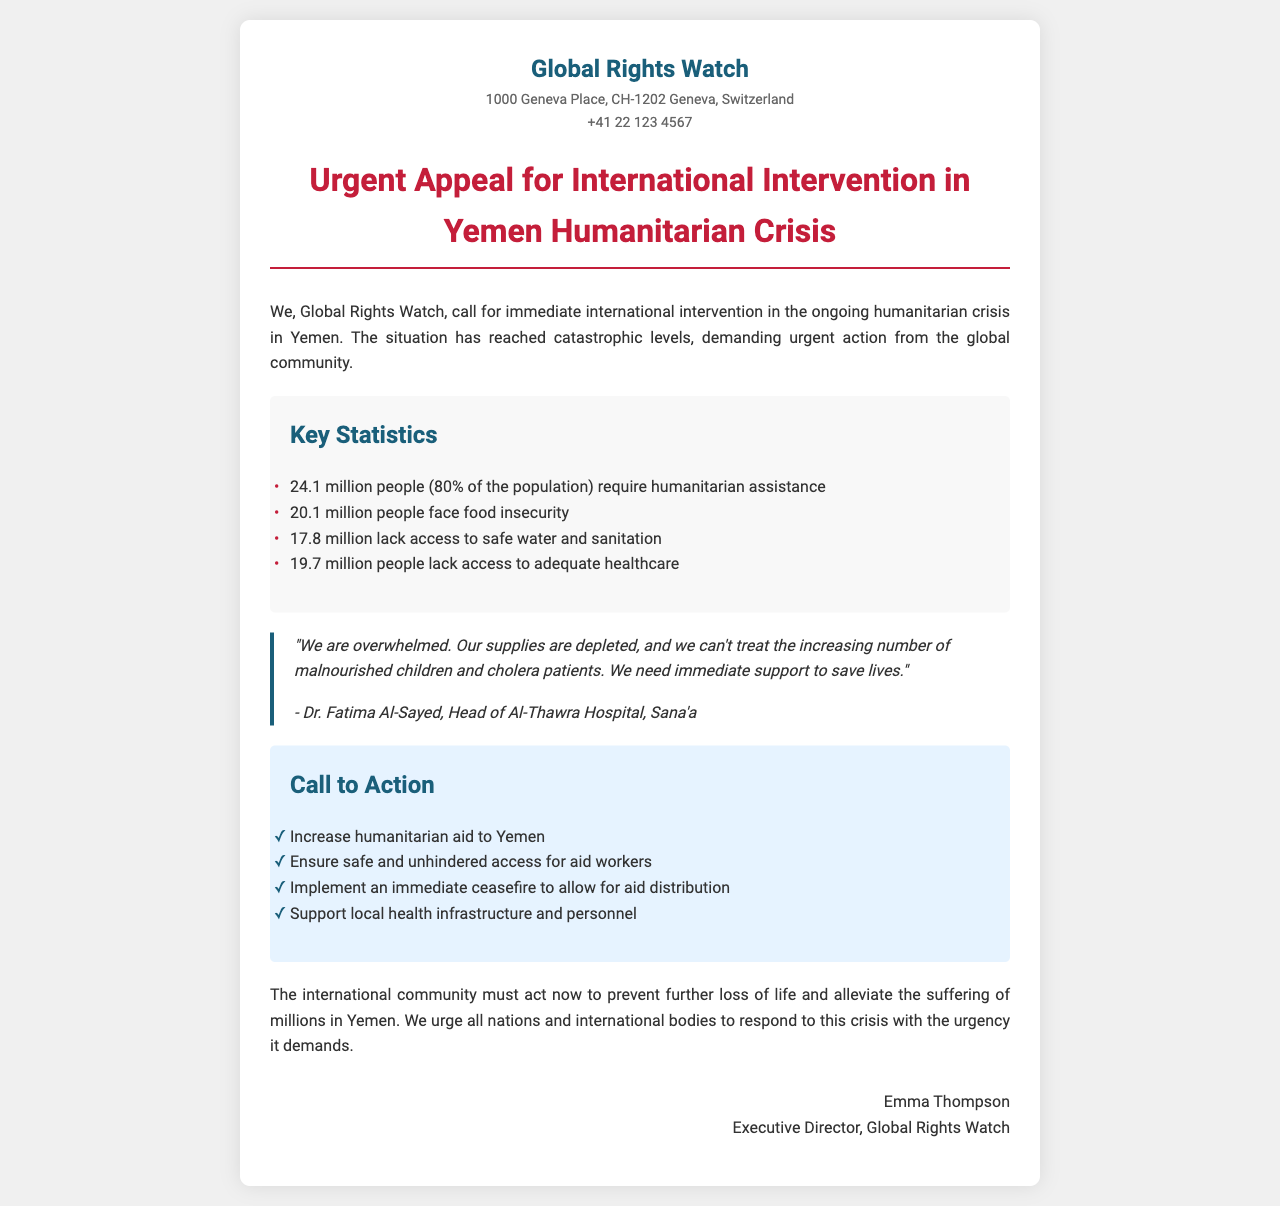what is the total number of people requiring humanitarian assistance in Yemen? The document states that 24.1 million people, which is 80% of the population, require humanitarian assistance.
Answer: 24.1 million how many people face food insecurity in Yemen? According to the statistics provided, 20.1 million people face food insecurity.
Answer: 20.1 million who is the head of Al-Thawra Hospital in Sana'a? The document quotes Dr. Fatima Al-Sayed as the Head of Al-Thawra Hospital in Sana'a.
Answer: Dr. Fatima Al-Sayed what is one of the key needs expressed by Dr. Fatima Al-Sayed? Dr. Fatima Al-Sayed states that they can't treat the increasing number of malnourished children and cholera patients.
Answer: immediate support what is one of the actions called for in the “Call to Action” section? The document lists several actions, such as ensuring safe and unhindered access for aid workers.
Answer: ensure safe and unhindered access what percentage of the population in Yemen lacks access to adequate healthcare? The document mentions that 19.7 million people lack access to adequate healthcare, which represents significant concern but does not explicitly state the percentage.
Answer: 19.7 million what is the main purpose of this document? The document calls for immediate international intervention regarding the humanitarian crisis in Yemen.
Answer: urgent appeal for international intervention what organization is sending out this fax? The organization identified in the document is Global Rights Watch.
Answer: Global Rights Watch how many people lack access to safe water and sanitation? The document states that 17.8 million people lack access to safe water and sanitation.
Answer: 17.8 million 